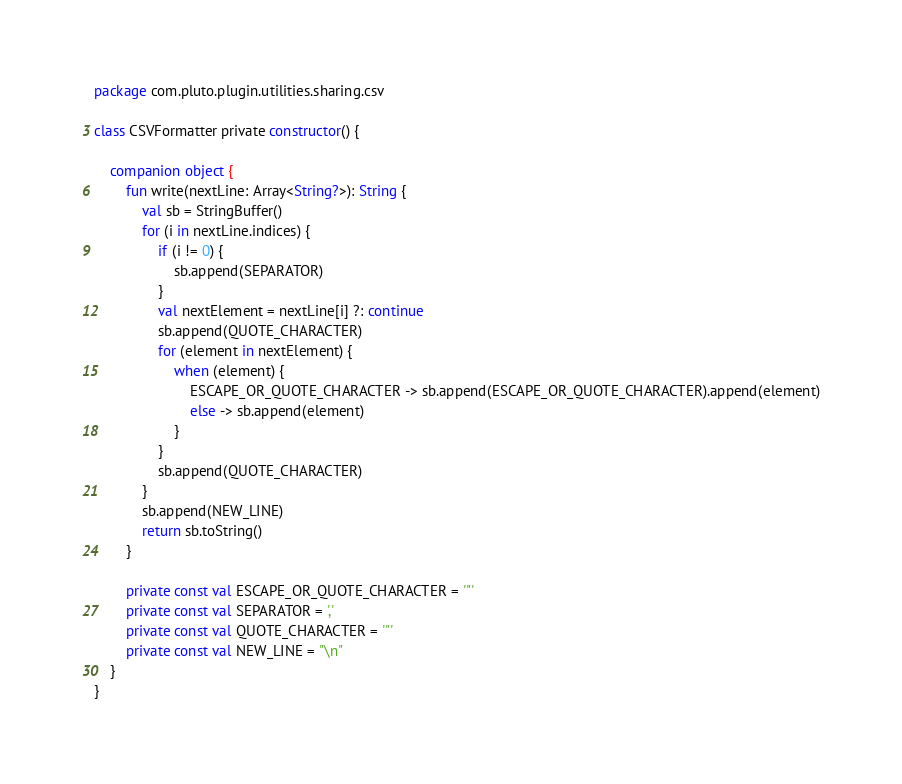Convert code to text. <code><loc_0><loc_0><loc_500><loc_500><_Kotlin_>package com.pluto.plugin.utilities.sharing.csv

class CSVFormatter private constructor() {

    companion object {
        fun write(nextLine: Array<String?>): String {
            val sb = StringBuffer()
            for (i in nextLine.indices) {
                if (i != 0) {
                    sb.append(SEPARATOR)
                }
                val nextElement = nextLine[i] ?: continue
                sb.append(QUOTE_CHARACTER)
                for (element in nextElement) {
                    when (element) {
                        ESCAPE_OR_QUOTE_CHARACTER -> sb.append(ESCAPE_OR_QUOTE_CHARACTER).append(element)
                        else -> sb.append(element)
                    }
                }
                sb.append(QUOTE_CHARACTER)
            }
            sb.append(NEW_LINE)
            return sb.toString()
        }

        private const val ESCAPE_OR_QUOTE_CHARACTER = '"'
        private const val SEPARATOR = ','
        private const val QUOTE_CHARACTER = '"'
        private const val NEW_LINE = "\n"
    }
}
</code> 